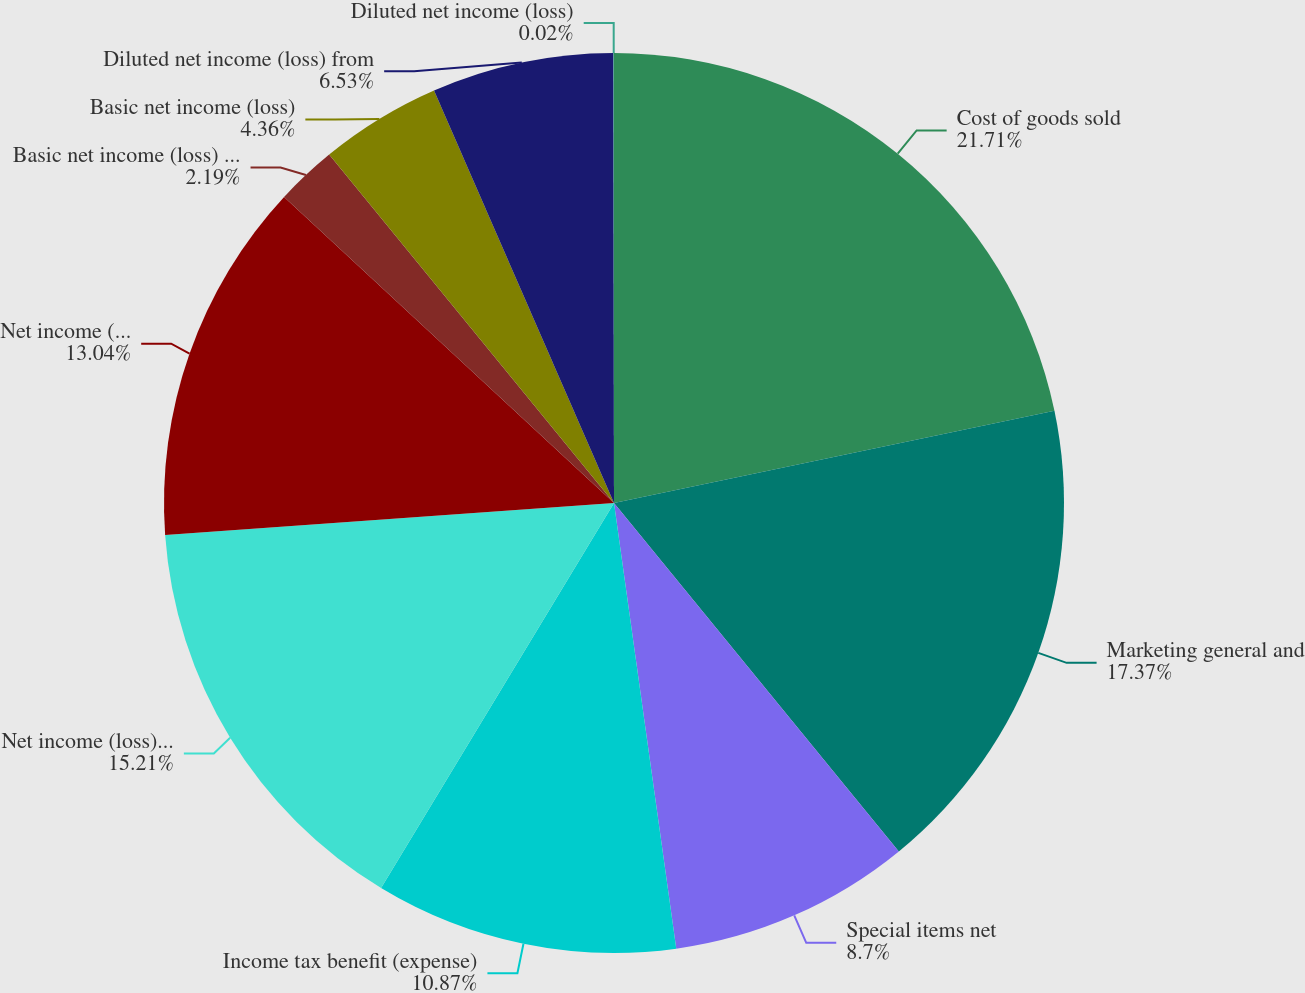Convert chart. <chart><loc_0><loc_0><loc_500><loc_500><pie_chart><fcel>Cost of goods sold<fcel>Marketing general and<fcel>Special items net<fcel>Income tax benefit (expense)<fcel>Net income (loss) from<fcel>Net income (loss) attributable<fcel>Basic net income (loss) from<fcel>Basic net income (loss)<fcel>Diluted net income (loss) from<fcel>Diluted net income (loss)<nl><fcel>21.72%<fcel>17.38%<fcel>8.7%<fcel>10.87%<fcel>15.21%<fcel>13.04%<fcel>2.19%<fcel>4.36%<fcel>6.53%<fcel>0.02%<nl></chart> 